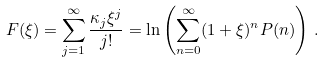<formula> <loc_0><loc_0><loc_500><loc_500>F ( \xi ) = \sum _ { j = 1 } ^ { \infty } \frac { \kappa _ { j } \xi ^ { j } } { j ! } = \ln \left ( \sum _ { n = 0 } ^ { \infty } ( 1 + \xi ) ^ { n } P ( n ) \right ) \, .</formula> 